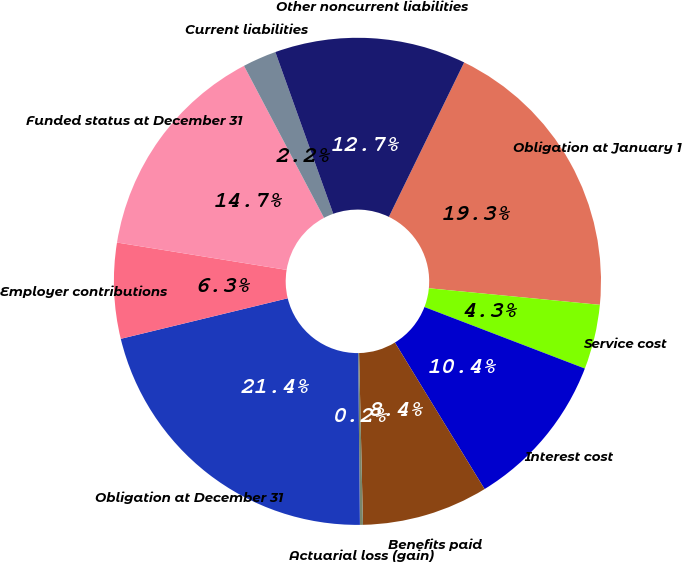Convert chart to OTSL. <chart><loc_0><loc_0><loc_500><loc_500><pie_chart><fcel>Obligation at January 1<fcel>Service cost<fcel>Interest cost<fcel>Benefits paid<fcel>Actuarial loss (gain)<fcel>Obligation at December 31<fcel>Employer contributions<fcel>Funded status at December 31<fcel>Current liabilities<fcel>Other noncurrent liabilities<nl><fcel>19.32%<fcel>4.29%<fcel>10.43%<fcel>8.38%<fcel>0.2%<fcel>21.37%<fcel>6.34%<fcel>14.74%<fcel>2.24%<fcel>12.69%<nl></chart> 